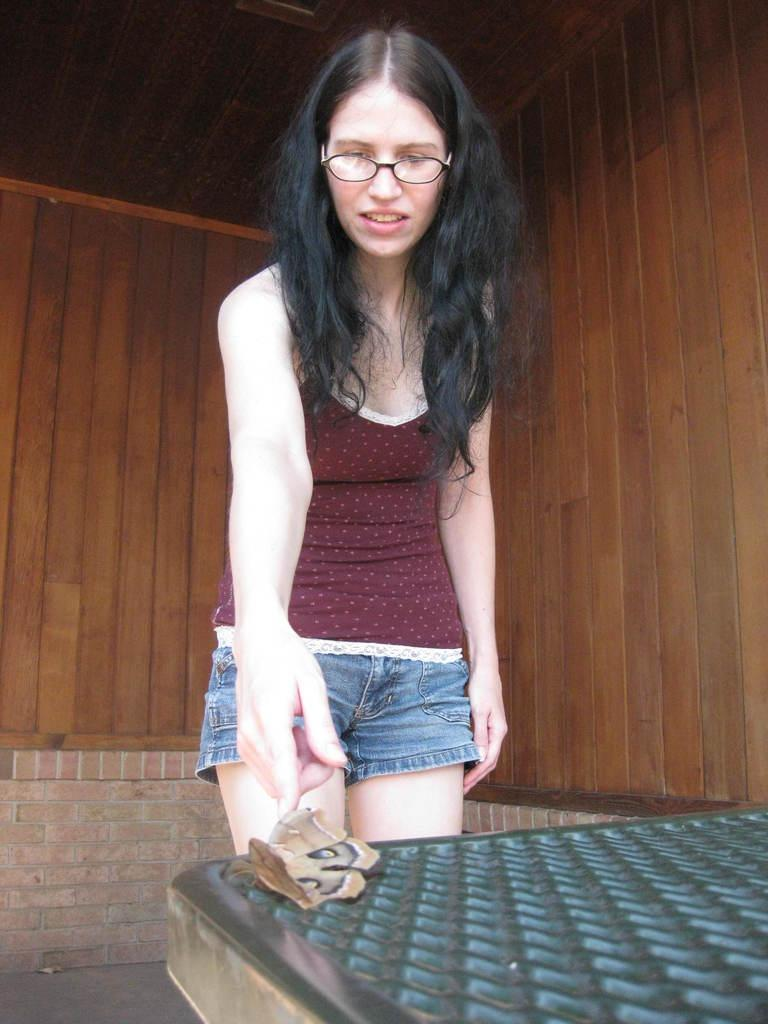Who is the main subject in the image? There is a woman in the image. What is the woman doing in the image? The woman is standing on the floor. Can you describe anything else in the image besides the woman? There is an insect on an object in front of the woman, and there is a wooden wall behind her. What type of scarf is the cow wearing in the image? There is no cow or scarf present in the image. How many grandmothers are visible in the image? There is no grandmother present in the image. 